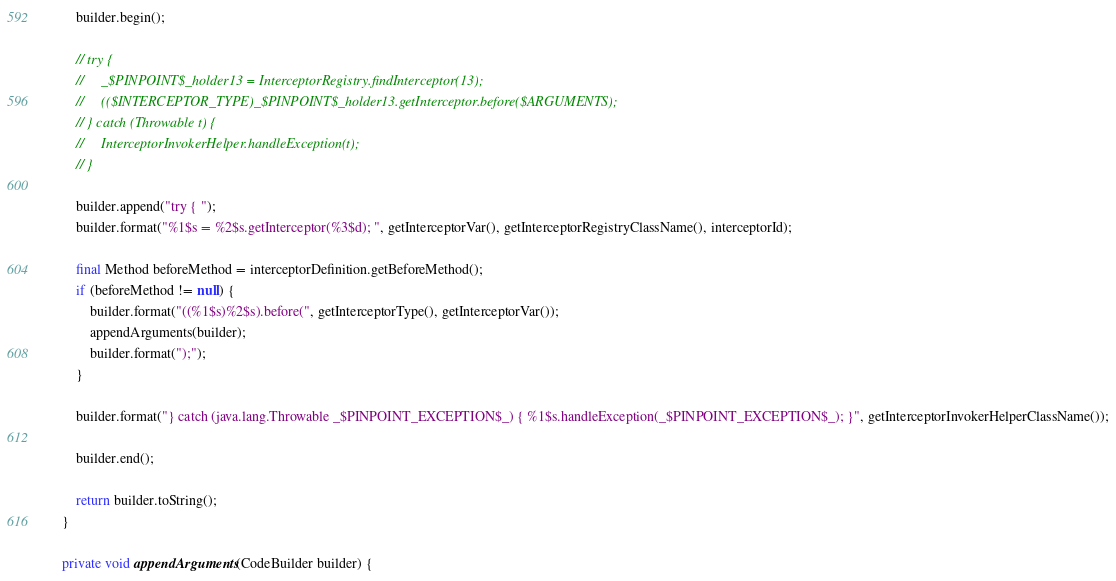<code> <loc_0><loc_0><loc_500><loc_500><_Java_>        builder.begin();

        // try {
        //     _$PINPOINT$_holder13 = InterceptorRegistry.findInterceptor(13);
        //     (($INTERCEPTOR_TYPE)_$PINPOINT$_holder13.getInterceptor.before($ARGUMENTS);
        // } catch (Throwable t) {
        //     InterceptorInvokerHelper.handleException(t);
        // }
        
        builder.append("try { ");
        builder.format("%1$s = %2$s.getInterceptor(%3$d); ", getInterceptorVar(), getInterceptorRegistryClassName(), interceptorId);

        final Method beforeMethod = interceptorDefinition.getBeforeMethod();
        if (beforeMethod != null) {
            builder.format("((%1$s)%2$s).before(", getInterceptorType(), getInterceptorVar());
            appendArguments(builder);
            builder.format(");");
        }
        
        builder.format("} catch (java.lang.Throwable _$PINPOINT_EXCEPTION$_) { %1$s.handleException(_$PINPOINT_EXCEPTION$_); }", getInterceptorInvokerHelperClassName());
        
        builder.end();
        
        return builder.toString();
    }

    private void appendArguments(CodeBuilder builder) {</code> 